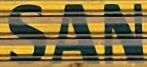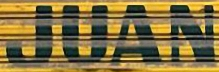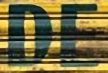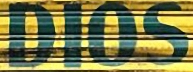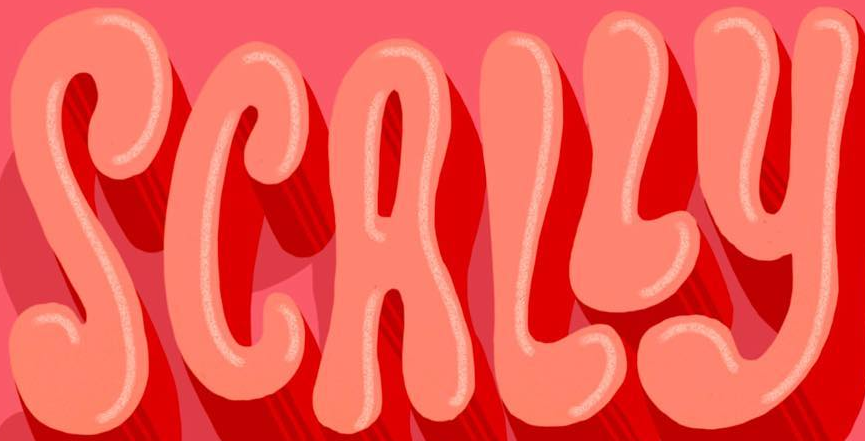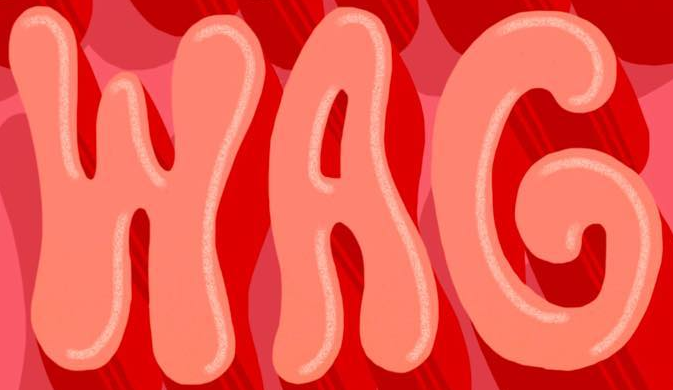What words are shown in these images in order, separated by a semicolon? SAN; JUAN; DE; DIOS; SCALLY; WAG 